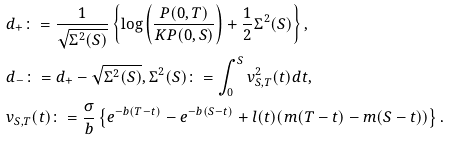Convert formula to latex. <formula><loc_0><loc_0><loc_500><loc_500>& d _ { + } \colon = \frac { 1 } { \sqrt { \Sigma ^ { 2 } ( S ) } } \left \{ \log \left ( \frac { P ( 0 , T ) } { K P ( 0 , S ) } \right ) + \frac { 1 } { 2 } \Sigma ^ { 2 } ( S ) \right \} , \\ & d _ { - } \colon = d _ { + } - \sqrt { \Sigma ^ { 2 } ( S ) } , \Sigma ^ { 2 } ( S ) \colon = \int _ { 0 } ^ { S } v _ { S , T } ^ { 2 } ( t ) d t , \\ & v _ { S , T } ( t ) \colon = \frac { \sigma } { b } \left \{ e ^ { - b ( T - t ) } - e ^ { - b ( S - t ) } + l ( t ) ( m ( T - t ) - m ( S - t ) ) \right \} .</formula> 